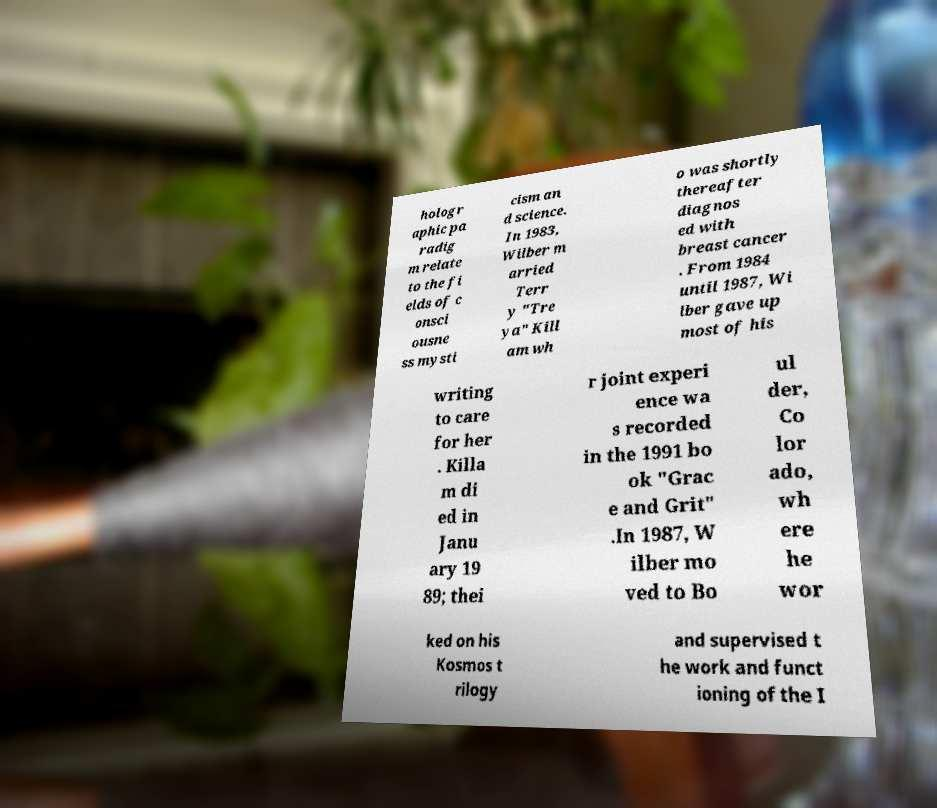Could you extract and type out the text from this image? hologr aphic pa radig m relate to the fi elds of c onsci ousne ss mysti cism an d science. In 1983, Wilber m arried Terr y "Tre ya" Kill am wh o was shortly thereafter diagnos ed with breast cancer . From 1984 until 1987, Wi lber gave up most of his writing to care for her . Killa m di ed in Janu ary 19 89; thei r joint experi ence wa s recorded in the 1991 bo ok "Grac e and Grit" .In 1987, W ilber mo ved to Bo ul der, Co lor ado, wh ere he wor ked on his Kosmos t rilogy and supervised t he work and funct ioning of the I 